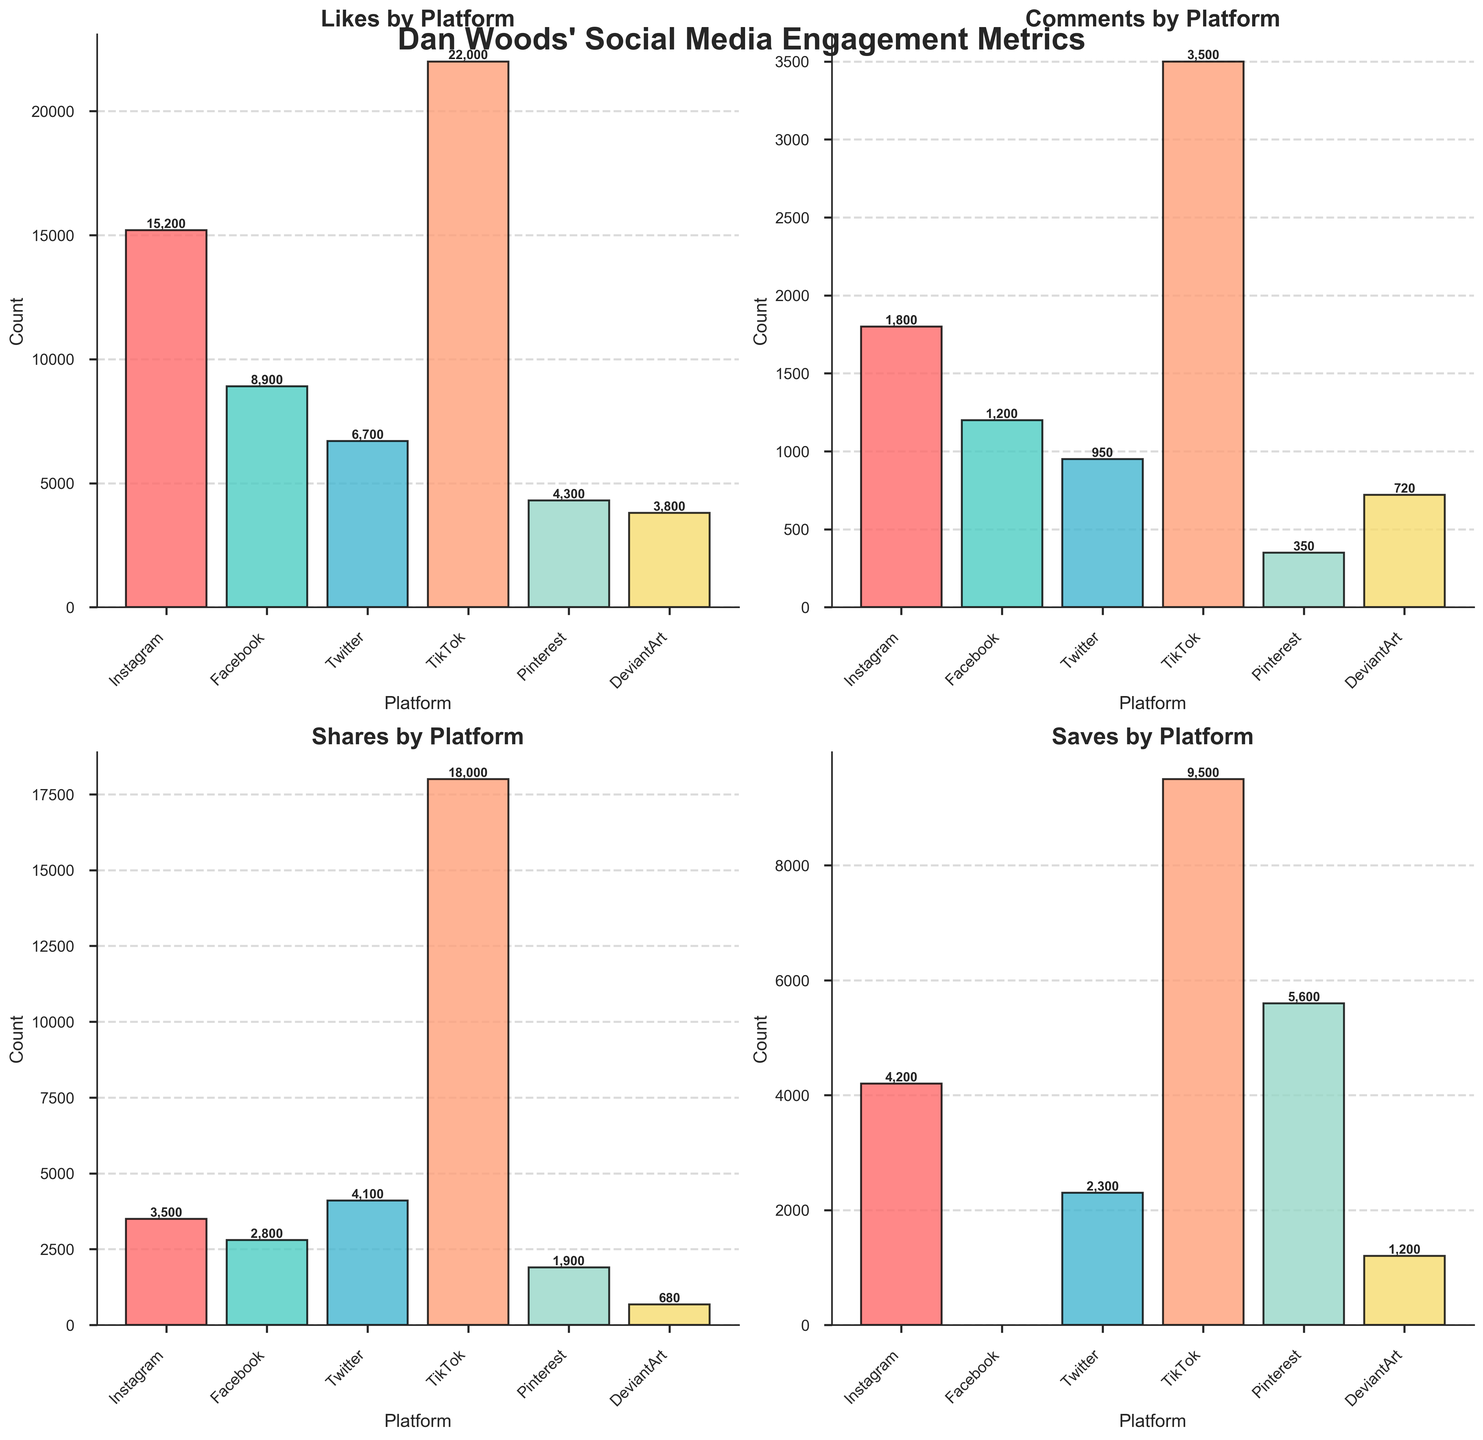what's the platform with the highest number of likes? Look at the `Likes` subplot and identify the tallest bar. Instagram has the highest bar.
Answer: Instagram How many comments does TikTok have? Find the `Comments` subplot and locate TikTok's bar. The bar is labeled 3,500.
Answer: 3,500 Which platform has the least number of shares? In the `Shares` subplot, locate the shortest bar. DeviantArt has the shortest bar.
Answer: DeviantArt What is the total number of saves across all platforms? Sum the values from the `Saves` subplot: 4200 (Instagram) + 2300 (Twitter) + 9500 (TikTok) + 5600 (Pinterest) + 1200 (DeviantArt). Facebook is excluded due to 'N/A'. The total is 22,800.
Answer: 22,800 How does Facebook compare to Instagram in terms of comments? Check the `Comments` subplot. Instagram has 1,800 comments, and Facebook has 1,200 comments. Instagram has more comments.
Answer: Instagram has more comments What is the difference in the number of saves between Pinterest and TikTok? Locate the `Saves` subplot, find the values for Pinterest (5,600) and TikTok (9,500), then subtract Pinterest's saves from TikTok's saves: 9,500 - 5,600 = 3,900.
Answer: 3,900 What percentage of the total likes are from Twitter? Find Twitter's likes (6,700) in the `Likes` subplot. Calculate the total likes by summing all platforms (15,200 + 8,900 + 6,700 + 22,000 + 4,300 + 3,800 = 60,900). To find the percentage: (6,700 / 60,900) * 100 ≈ 11.0%.
Answer: 11.0% Which platform has the second highest amount of shares? In the `Shares` subplot, identify the second tallest bar after TikTok (18,000). Twitter has the next highest at 4,100.
Answer: Twitter Does DeviantArt have more comments or shares? Look at both the `Comments` and `Shares` subplots. DeviantArt has 720 comments and 680 shares. Comments are higher.
Answer: Comments Does any platform have the same number of comments and shares? Compare the values in both `Comments` and `Shares` plots for each platform. No platform has equal numbers for comments and shares.
Answer: No 